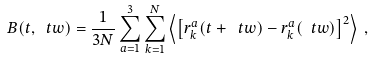Convert formula to latex. <formula><loc_0><loc_0><loc_500><loc_500>B ( t , \ t w ) = \frac { 1 } { 3 N } \sum _ { a = 1 } ^ { 3 } \sum _ { k = 1 } ^ { N } \left \langle \left [ r _ { k } ^ { a } ( t + \ t w ) - r _ { k } ^ { a } ( \ t w ) \right ] ^ { 2 } \right \rangle \, ,</formula> 